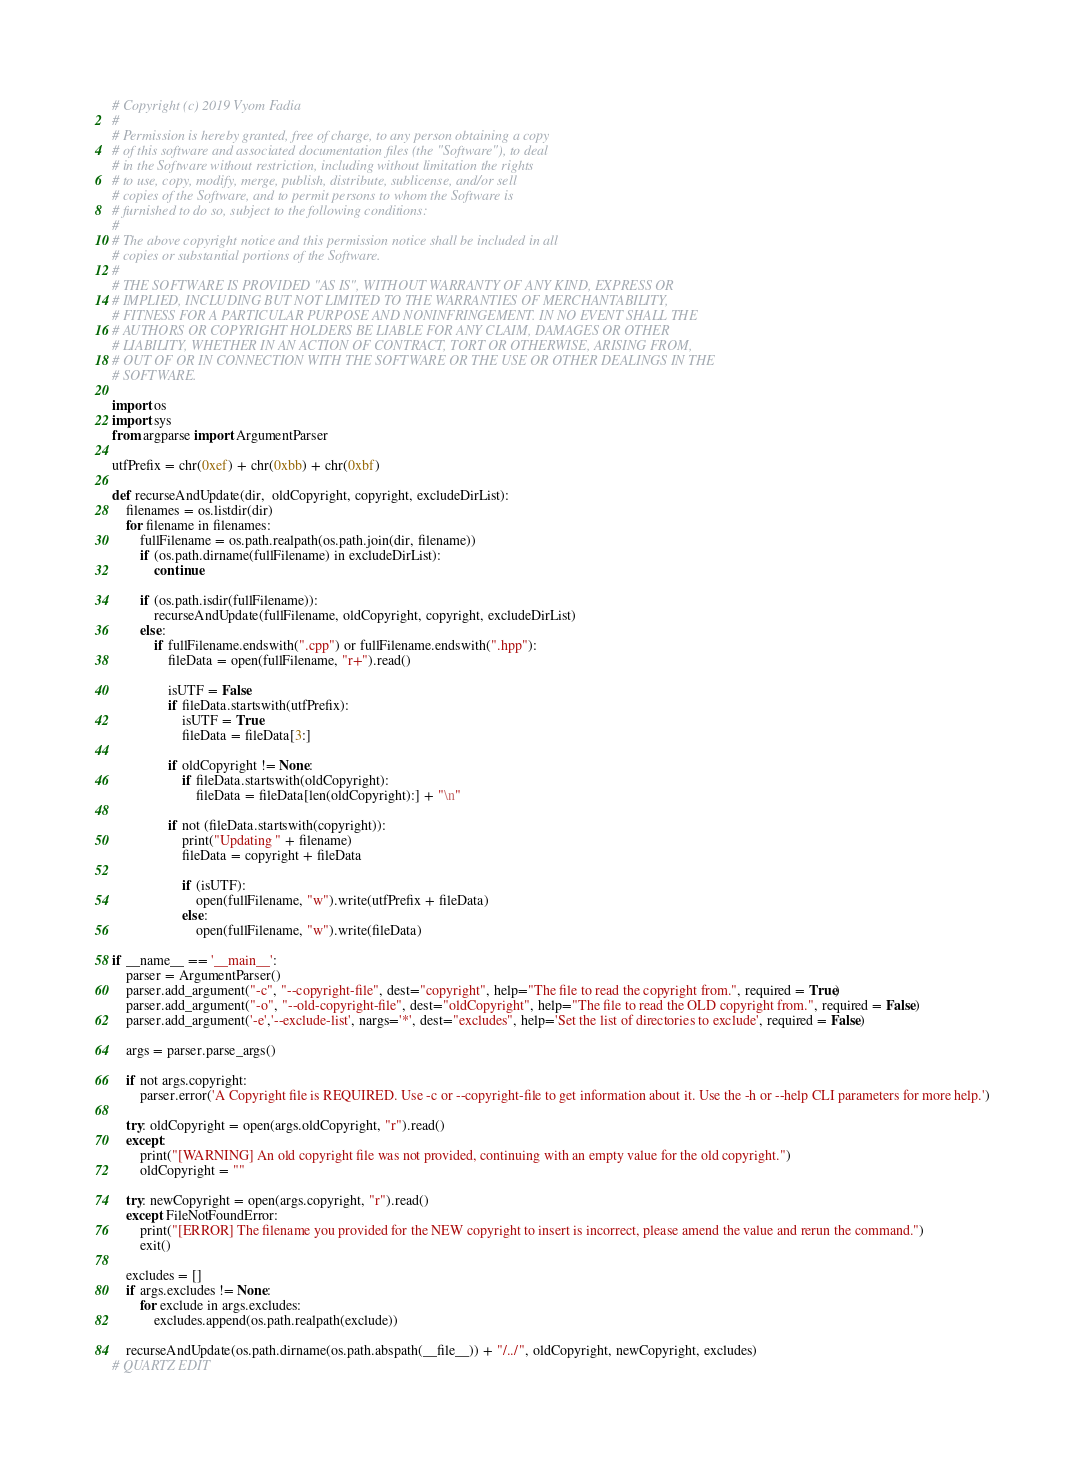Convert code to text. <code><loc_0><loc_0><loc_500><loc_500><_Python_># Copyright (c) 2019 Vyom Fadia
#
# Permission is hereby granted, free of charge, to any person obtaining a copy
# of this software and associated documentation files (the "Software"), to deal
# in the Software without restriction, including without limitation the rights
# to use, copy, modify, merge, publish, distribute, sublicense, and/or sell
# copies of the Software, and to permit persons to whom the Software is
# furnished to do so, subject to the following conditions:
#
# The above copyright notice and this permission notice shall be included in all
# copies or substantial portions of the Software.
#
# THE SOFTWARE IS PROVIDED "AS IS", WITHOUT WARRANTY OF ANY KIND, EXPRESS OR
# IMPLIED, INCLUDING BUT NOT LIMITED TO THE WARRANTIES OF MERCHANTABILITY,
# FITNESS FOR A PARTICULAR PURPOSE AND NONINFRINGEMENT. IN NO EVENT SHALL THE
# AUTHORS OR COPYRIGHT HOLDERS BE LIABLE FOR ANY CLAIM, DAMAGES OR OTHER
# LIABILITY, WHETHER IN AN ACTION OF CONTRACT, TORT OR OTHERWISE, ARISING FROM,
# OUT OF OR IN CONNECTION WITH THE SOFTWARE OR THE USE OR OTHER DEALINGS IN THE
# SOFTWARE.

import os
import sys
from argparse import ArgumentParser

utfPrefix = chr(0xef) + chr(0xbb) + chr(0xbf)

def recurseAndUpdate(dir,  oldCopyright, copyright, excludeDirList):
    filenames = os.listdir(dir)
    for filename in filenames:
        fullFilename = os.path.realpath(os.path.join(dir, filename))
        if (os.path.dirname(fullFilename) in excludeDirList):
            continue

        if (os.path.isdir(fullFilename)):
            recurseAndUpdate(fullFilename, oldCopyright, copyright, excludeDirList)
        else:
            if fullFilename.endswith(".cpp") or fullFilename.endswith(".hpp"):
                fileData = open(fullFilename, "r+").read()
                
                isUTF = False
                if fileData.startswith(utfPrefix):
                    isUTF = True
                    fileData = fileData[3:]
                
                if oldCopyright != None:
                    if fileData.startswith(oldCopyright):
                        fileData = fileData[len(oldCopyright):] + "\n"

                if not (fileData.startswith(copyright)):
                    print("Updating " + filename)
                    fileData = copyright + fileData

                    if (isUTF):
                        open(fullFilename, "w").write(utfPrefix + fileData)
                    else:
                        open(fullFilename, "w").write(fileData)

if __name__ == '__main__':
    parser = ArgumentParser()
    parser.add_argument("-c", "--copyright-file", dest="copyright", help="The file to read the copyright from.", required = True)
    parser.add_argument("-o", "--old-copyright-file", dest="oldCopyright", help="The file to read the OLD copyright from.", required = False)
    parser.add_argument('-e','--exclude-list', nargs='*', dest="excludes", help='Set the list of directories to exclude', required = False)

    args = parser.parse_args()

    if not args.copyright:
        parser.error('A Copyright file is REQUIRED. Use -c or --copyright-file to get information about it. Use the -h or --help CLI parameters for more help.')

    try: oldCopyright = open(args.oldCopyright, "r").read()
    except:
        print("[WARNING] An old copyright file was not provided, continuing with an empty value for the old copyright.") 
        oldCopyright = ""
    
    try: newCopyright = open(args.copyright, "r").read()
    except FileNotFoundError:
        print("[ERROR] The filename you provided for the NEW copyright to insert is incorrect, please amend the value and rerun the command.")
        exit()

    excludes = []
    if args.excludes != None:
        for exclude in args.excludes:
            excludes.append(os.path.realpath(exclude))
            
    recurseAndUpdate(os.path.dirname(os.path.abspath(__file__)) + "/../", oldCopyright, newCopyright, excludes) 
# QUARTZ EDIT
</code> 